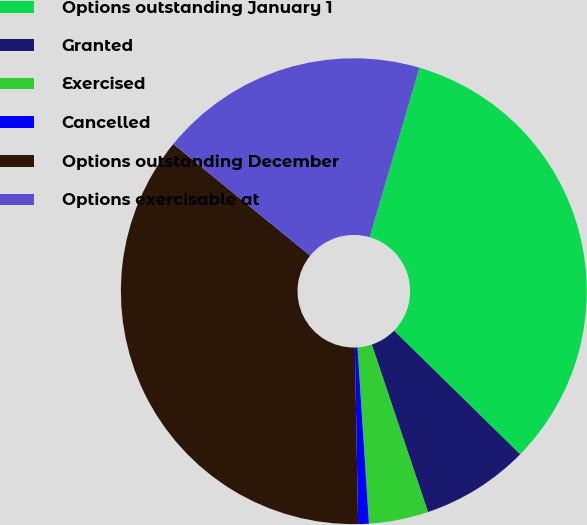Convert chart to OTSL. <chart><loc_0><loc_0><loc_500><loc_500><pie_chart><fcel>Options outstanding January 1<fcel>Granted<fcel>Exercised<fcel>Cancelled<fcel>Options outstanding December<fcel>Options exercisable at<nl><fcel>32.8%<fcel>7.5%<fcel>4.12%<fcel>0.74%<fcel>36.18%<fcel>18.66%<nl></chart> 